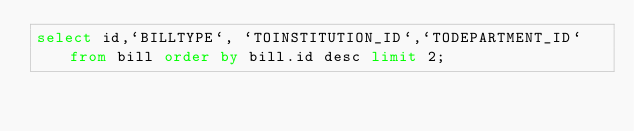<code> <loc_0><loc_0><loc_500><loc_500><_SQL_>select id,`BILLTYPE`, `TOINSTITUTION_ID`,`TODEPARTMENT_ID` from bill order by bill.id desc limit 2;
</code> 